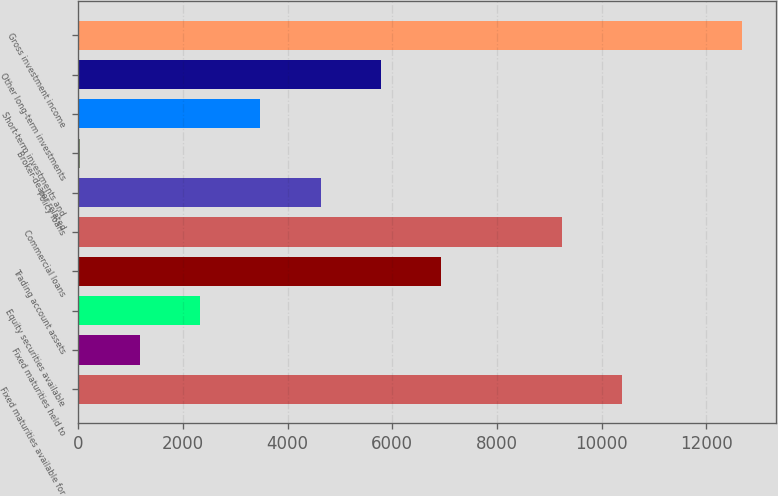<chart> <loc_0><loc_0><loc_500><loc_500><bar_chart><fcel>Fixed maturities available for<fcel>Fixed maturities held to<fcel>Equity securities available<fcel>Trading account assets<fcel>Commercial loans<fcel>Policy loans<fcel>Broker-dealer related<fcel>Short-term investments and<fcel>Other long-term investments<fcel>Gross investment income<nl><fcel>10389.7<fcel>1179.3<fcel>2330.6<fcel>6935.8<fcel>9238.4<fcel>4633.2<fcel>28<fcel>3481.9<fcel>5784.5<fcel>12692.3<nl></chart> 